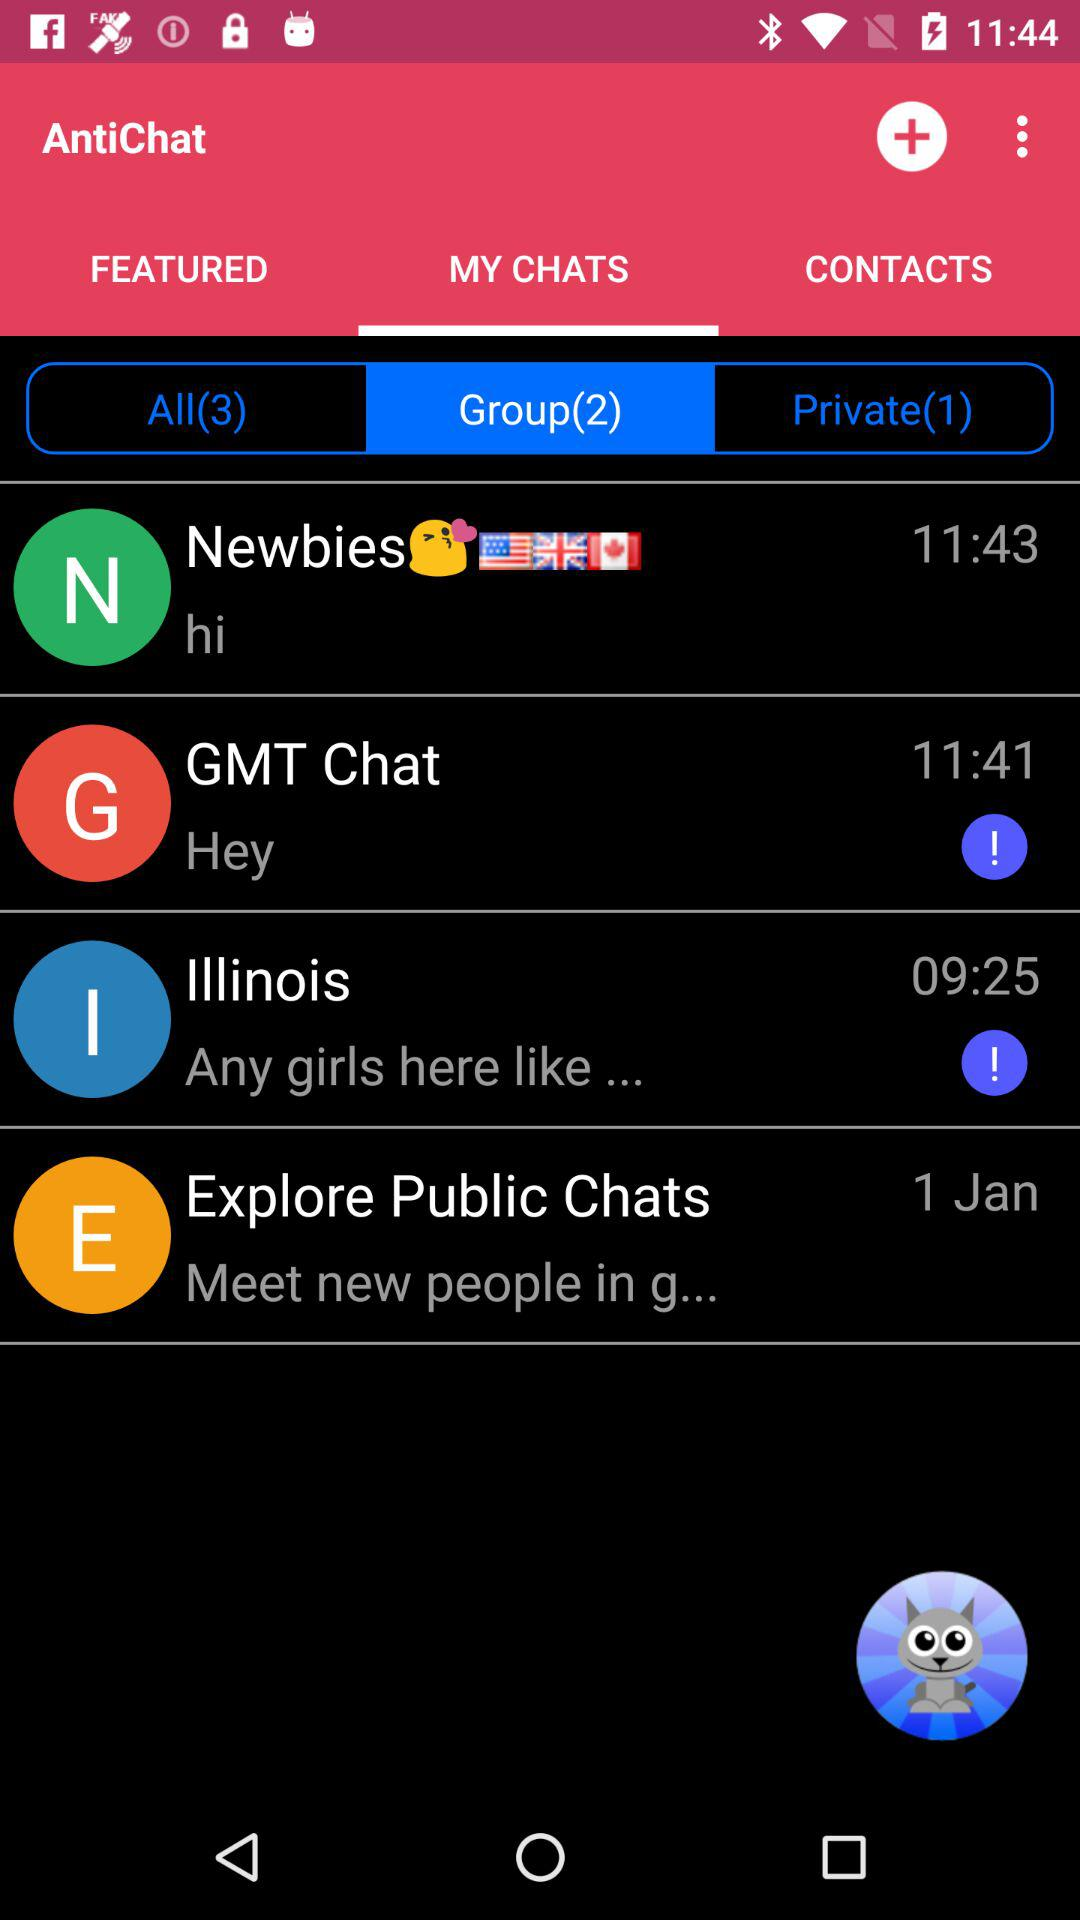How many groups are in "AntiChat"? There are 2 groups in "AntiChat". 